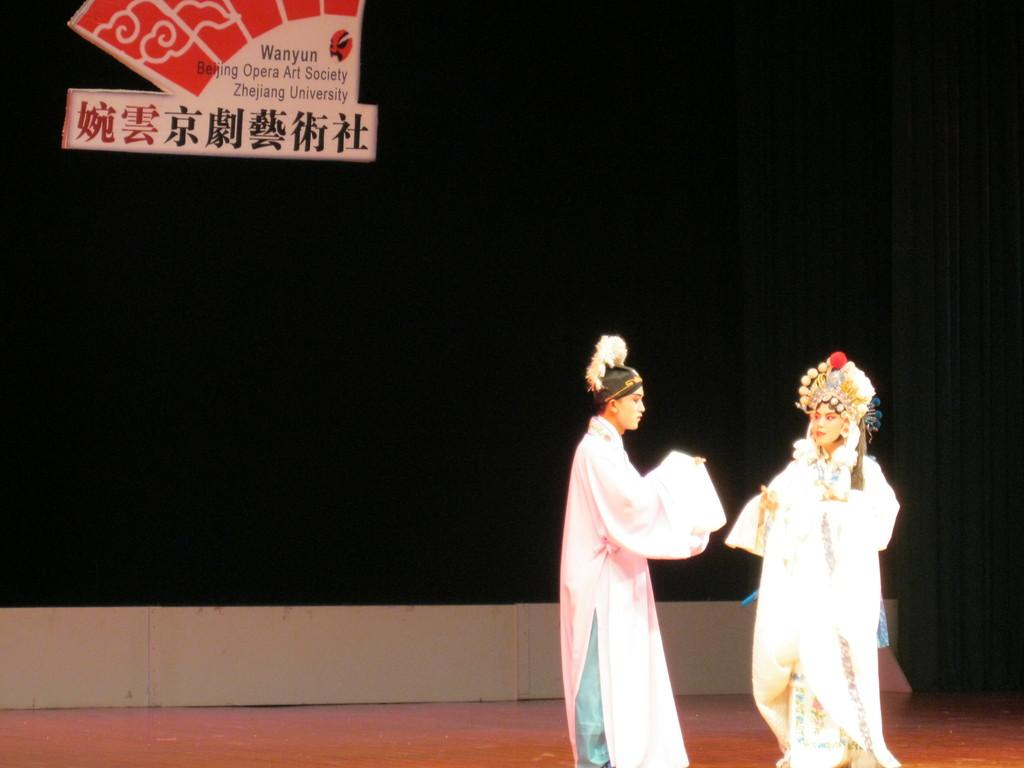How many people are in the image? There are two persons in the image. What are the persons wearing? The persons are wearing fancy dresses. What are the persons doing in the image? The persons are standing. What can be seen in the background of the image? There is a board in the background of the image. Are the two persons in the image sisters? There is no information in the image to determine if the two persons are sisters or not. What type of quiver is visible in the image? There is no quiver present in the image. 